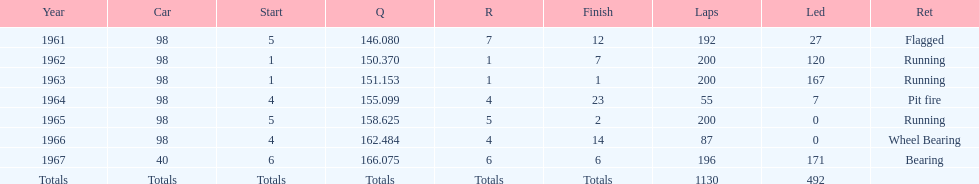What car ranked #1 from 1962-1963? 98. 